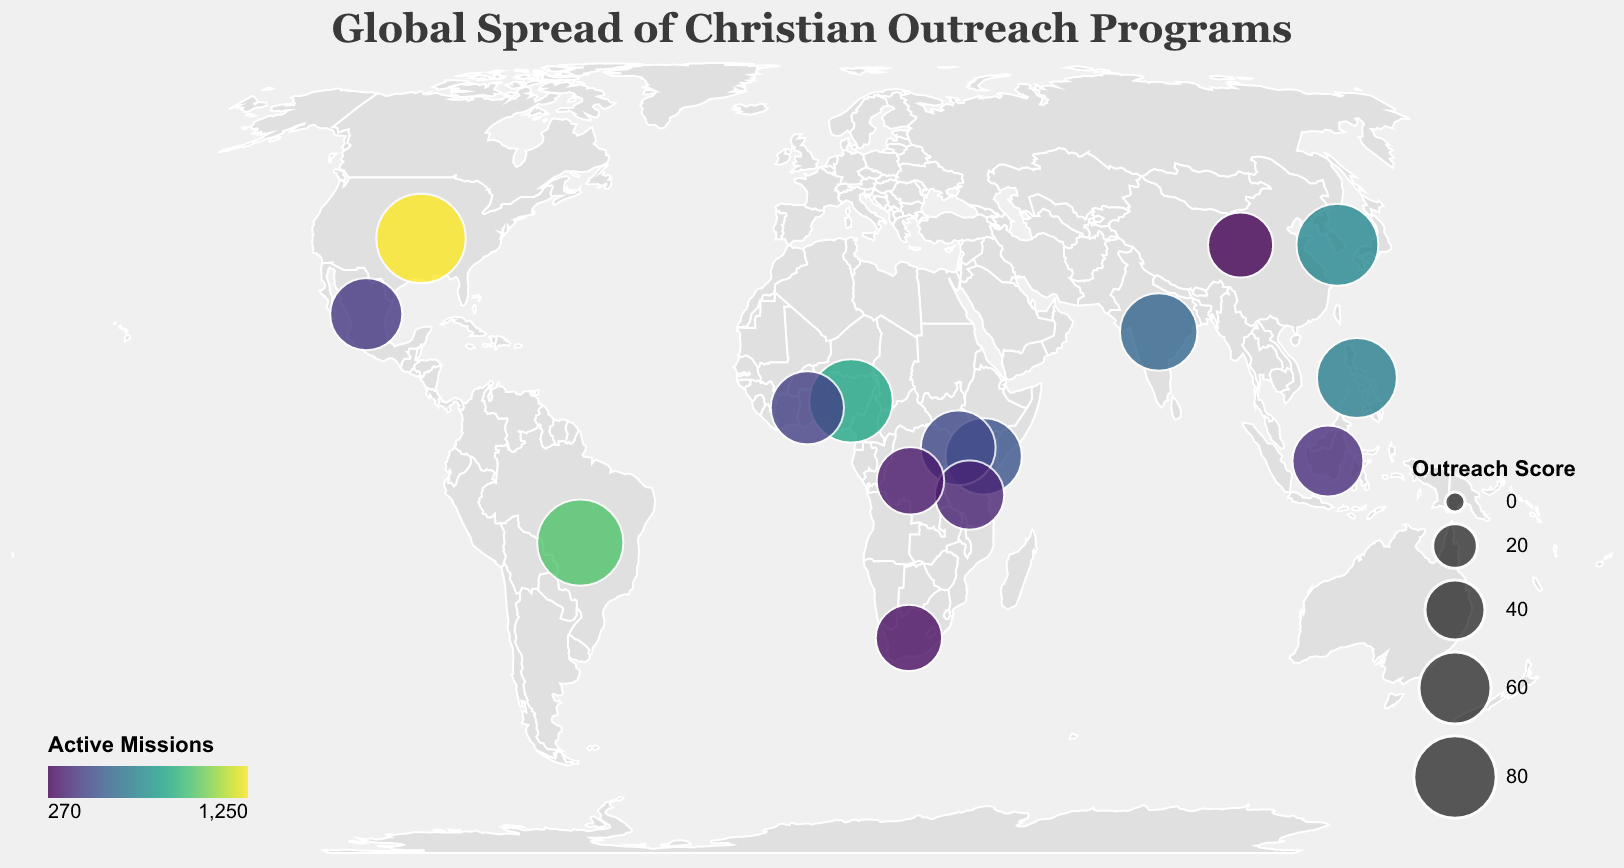What is the title of the figure? The title is displayed prominently at the top of the figure in a larger font.
Answer: Global Spread of Christian Outreach Programs Which country has the highest number of active missions? The legend indicating "Active Missions" is color-coded, and the tooltip provides details about each country when hovered over. The United States has the highest number of active missions.
Answer: United States How many Faith Healing Programs are in Nigeria? Hovering over Nigeria shows the tooltip that includes the "Faith Healing Programs" field.
Answer: 280 Which two countries have an Outreach Score of exactly 55? By scanning the data points or using the tooltip for precise values, Tanzania has an Outreach Score of 55, and no other country matches this score.
Answer: Tanzania (Only one country) Compare the number of Active Missions in the Philippines and South Korea. Which one has more? Looking at the color intensity of the markers or referring to the tooltip, the Philippines has 680 active missions while South Korea has 720.
Answer: South Korea What is the total Outreach Score for Brazil and Uganda combined? Locate the Outreach Scores for Brazil (88) and Uganda (65) in the tooltip, then add them together.
Answer: 153 Which country in Africa has the highest number of Active Missions? Narrow the search to African countries, then check the tooltip or color intensity of markers. Nigeria has the highest with 850 active missions.
Answer: Nigeria What is the range of Outreach Scores displayed on the map? Identify the minimum and maximum values from the tooltip data for all countries. The smallest score is 48 (China) and the highest is 95 (United States).
Answer: 48 to 95 How does the number of Faith Healing Programs in Mexico compare to that in Kenya? Use the tooltip to find that Mexico has 130 Faith Healing Programs while Kenya has 180.
Answer: Kenya has more Which country in Asia has the highest Outreach Score? Focus on Asian countries and check the tooltip data; South Korea has the highest Outreach Score of 79.
Answer: South Korea 